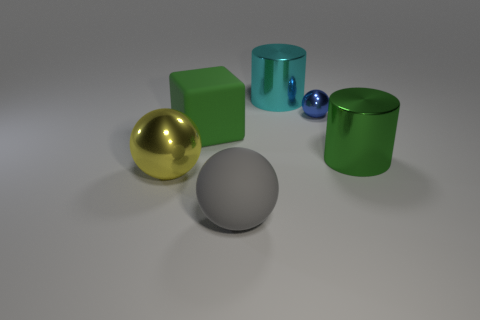Is the cyan metallic object the same shape as the green shiny object?
Ensure brevity in your answer.  Yes. There is a shiny thing to the left of the matte block; is its shape the same as the big rubber thing in front of the large green metallic cylinder?
Your answer should be compact. Yes. Do the gray object and the large green cylinder have the same material?
Offer a terse response. No. There is a sphere right of the big cylinder that is left of the cylinder that is to the right of the small metal ball; what is its size?
Provide a short and direct response. Small. Is there a metallic thing to the right of the shiny sphere behind the metal ball that is in front of the green shiny thing?
Make the answer very short. Yes. Is there a metal thing that has the same size as the yellow shiny sphere?
Keep it short and to the point. Yes. There is a green cylinder that is the same size as the matte ball; what is its material?
Your answer should be compact. Metal. Does the gray sphere have the same size as the green thing to the left of the cyan thing?
Provide a succinct answer. Yes. What number of rubber objects are large brown things or cylinders?
Your response must be concise. 0. What number of big things are the same shape as the small blue shiny object?
Offer a very short reply. 2. 